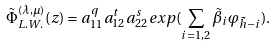Convert formula to latex. <formula><loc_0><loc_0><loc_500><loc_500>\tilde { \Phi } _ { L . W . } ^ { ( \lambda , \mu ) } ( z ) = a _ { 1 1 } ^ { q } a _ { 1 2 } ^ { t } a _ { 2 2 } ^ { s } e x p ( \sum _ { i = 1 , 2 } \tilde { \beta } _ { i } \varphi _ { \tilde { h } - i } ) .</formula> 